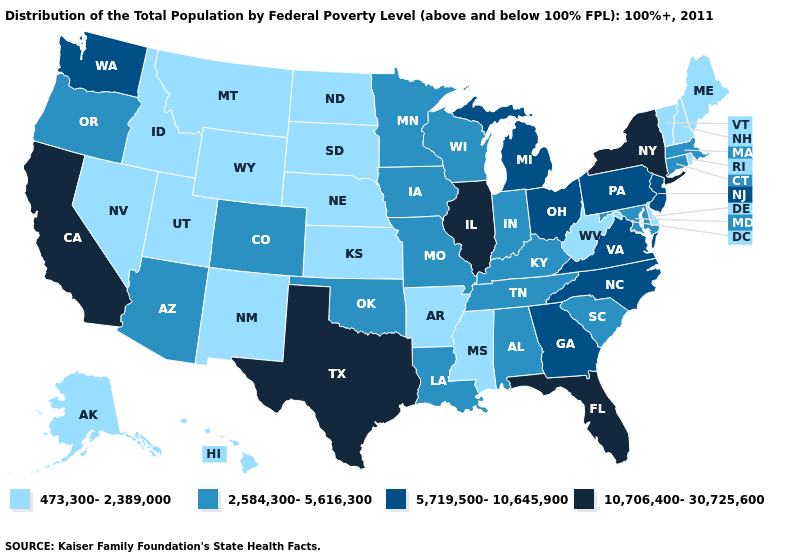Name the states that have a value in the range 2,584,300-5,616,300?
Concise answer only. Alabama, Arizona, Colorado, Connecticut, Indiana, Iowa, Kentucky, Louisiana, Maryland, Massachusetts, Minnesota, Missouri, Oklahoma, Oregon, South Carolina, Tennessee, Wisconsin. What is the value of California?
Answer briefly. 10,706,400-30,725,600. Name the states that have a value in the range 2,584,300-5,616,300?
Concise answer only. Alabama, Arizona, Colorado, Connecticut, Indiana, Iowa, Kentucky, Louisiana, Maryland, Massachusetts, Minnesota, Missouri, Oklahoma, Oregon, South Carolina, Tennessee, Wisconsin. Does the first symbol in the legend represent the smallest category?
Quick response, please. Yes. What is the highest value in the MidWest ?
Be succinct. 10,706,400-30,725,600. Name the states that have a value in the range 10,706,400-30,725,600?
Give a very brief answer. California, Florida, Illinois, New York, Texas. Name the states that have a value in the range 5,719,500-10,645,900?
Short answer required. Georgia, Michigan, New Jersey, North Carolina, Ohio, Pennsylvania, Virginia, Washington. How many symbols are there in the legend?
Answer briefly. 4. Among the states that border North Carolina , does Tennessee have the highest value?
Give a very brief answer. No. Name the states that have a value in the range 2,584,300-5,616,300?
Short answer required. Alabama, Arizona, Colorado, Connecticut, Indiana, Iowa, Kentucky, Louisiana, Maryland, Massachusetts, Minnesota, Missouri, Oklahoma, Oregon, South Carolina, Tennessee, Wisconsin. Name the states that have a value in the range 2,584,300-5,616,300?
Quick response, please. Alabama, Arizona, Colorado, Connecticut, Indiana, Iowa, Kentucky, Louisiana, Maryland, Massachusetts, Minnesota, Missouri, Oklahoma, Oregon, South Carolina, Tennessee, Wisconsin. What is the value of Alaska?
Write a very short answer. 473,300-2,389,000. What is the value of New Mexico?
Short answer required. 473,300-2,389,000. Which states have the highest value in the USA?
Be succinct. California, Florida, Illinois, New York, Texas. What is the value of New Hampshire?
Quick response, please. 473,300-2,389,000. 